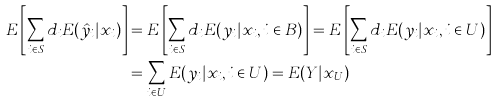Convert formula to latex. <formula><loc_0><loc_0><loc_500><loc_500>E \left [ \sum _ { i \in S } d _ { i } E ( \hat { y } _ { i } | x _ { i } ) \right ] & = E \left [ \sum _ { i \in S } d _ { i } E ( y _ { i } | x _ { i } , i \in B ) \right ] = E \left [ \sum _ { i \in S } d _ { i } E ( y _ { i } | x _ { i } , i \in U ) \right ] \\ & = \sum _ { i \in U } E ( y _ { i } | x _ { i } , i \in U ) = E ( Y | x _ { U } )</formula> 